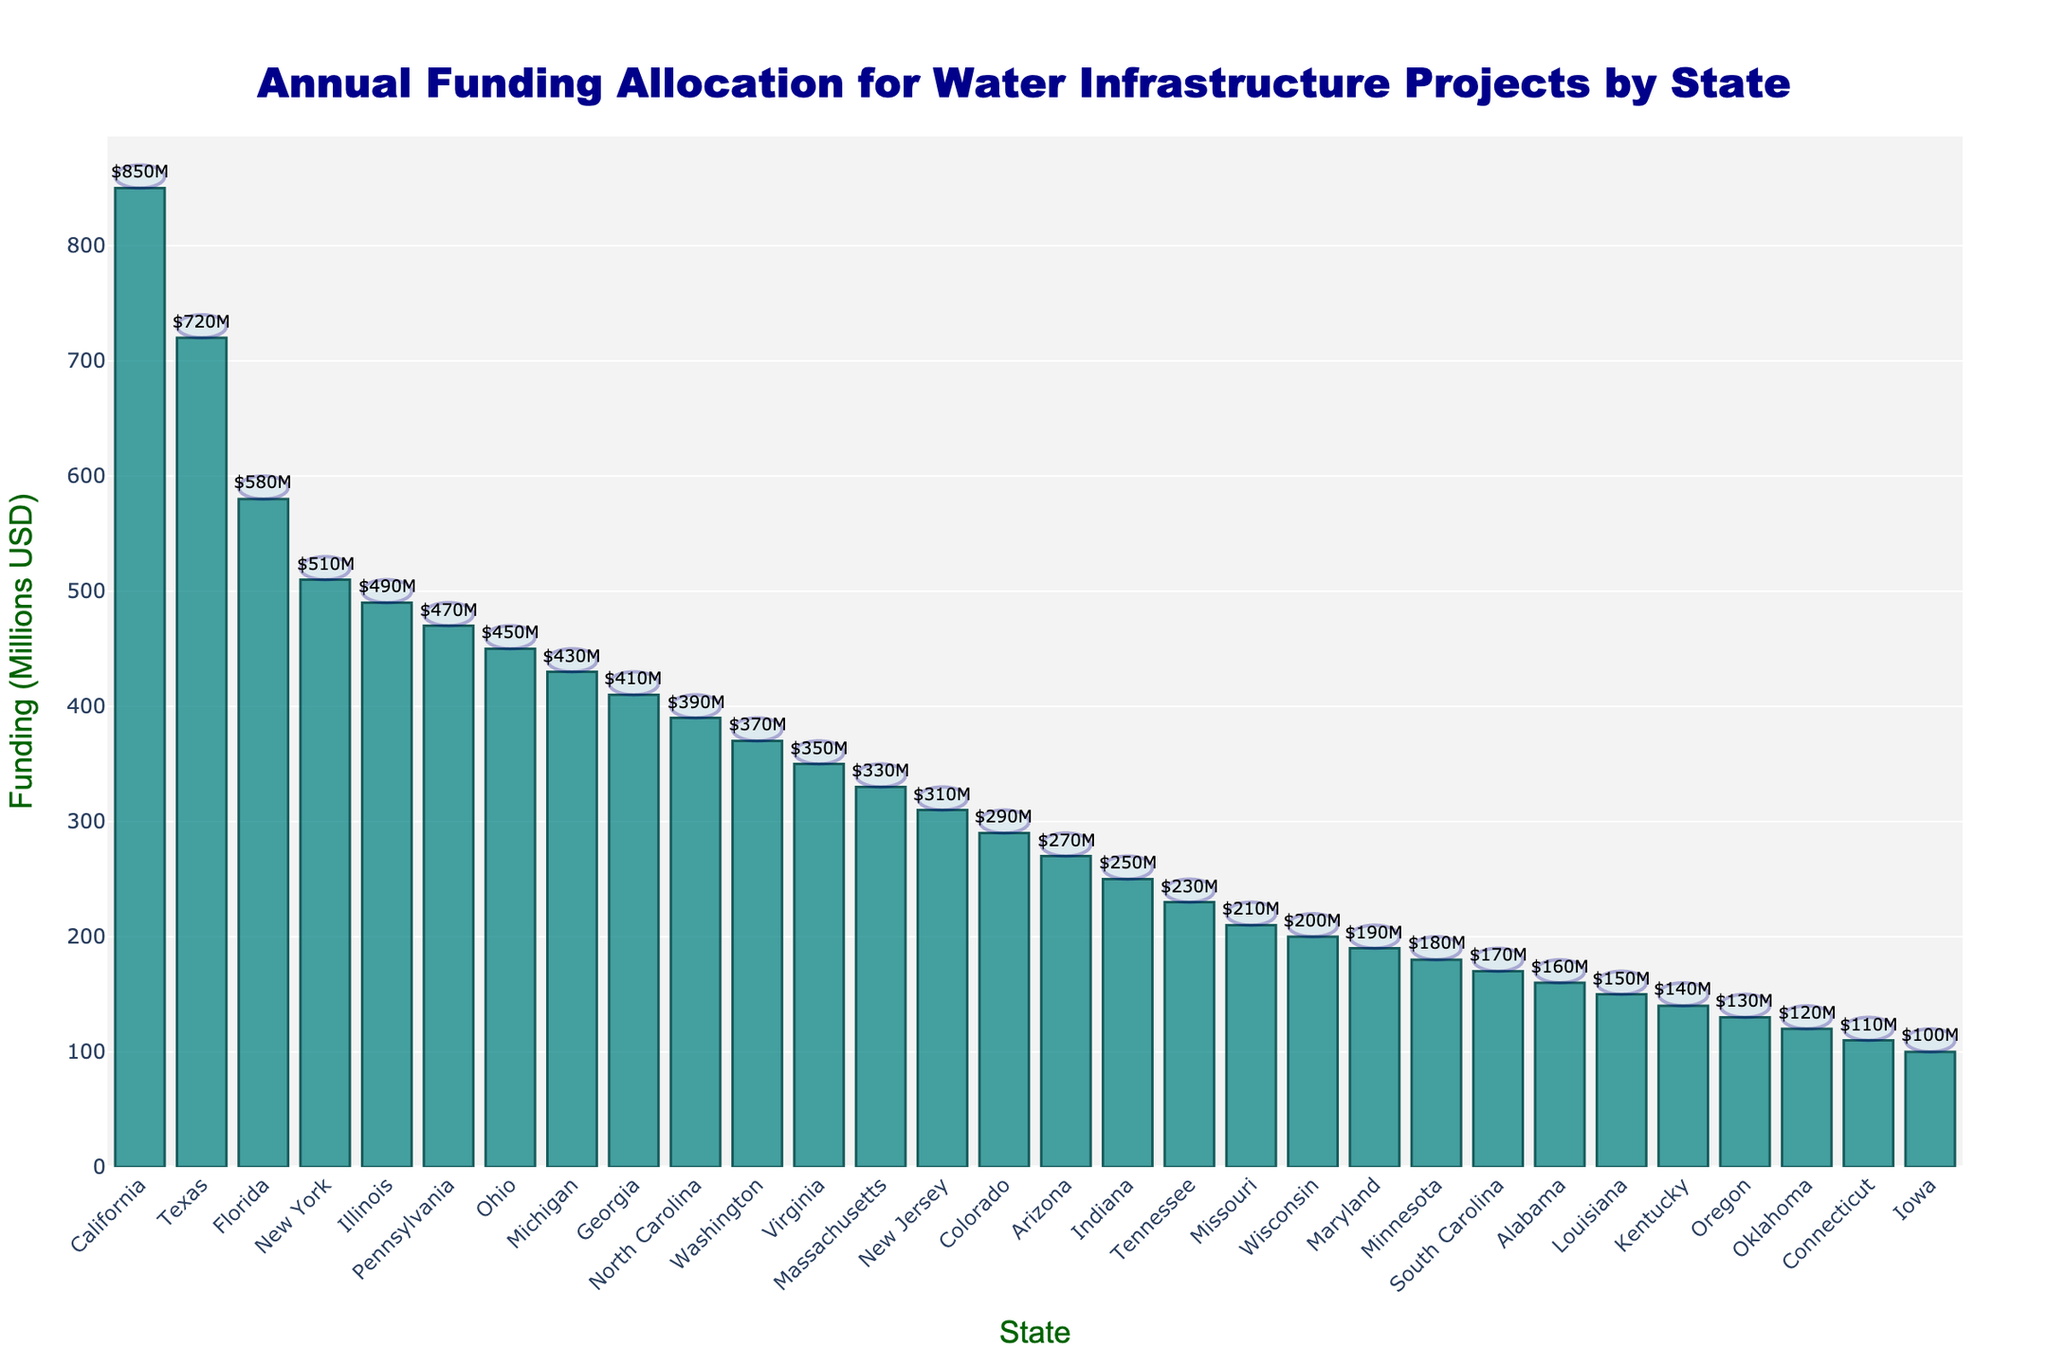Which state has the highest annual funding allocation for water infrastructure projects? By inspecting the height of the bars, we see that the bar representing California extends the highest on the y-axis, indicating this state has the greatest funding allocation.
Answer: California What's the total annual funding allocation for the top three states? Identify the top three states by the height of their bars: California ($850M), Texas ($720M), and Florida ($580M). Sum them: $850M + $720M + $580M = $2150M.
Answer: $2150M How much more funding does California receive compared to New York? Find the funding for California ($850M) and New York ($510M). Calculate the difference: $850M - $510M = $340M.
Answer: $340M Which states have funding allocations below $150M? Visually inspect the bars shorter than $150M. These states are Louisiana, Kentucky, Oregon, Oklahoma, Connecticut, and Iowa.
Answer: Louisiana, Kentucky, Oregon, Oklahoma, Connecticut, Iowa What's the average annual funding allocation for all states shown? Sum all funding values and divide by the number of states. Sum: $15460M. Number of states: 30. Average: $15460M / 30 = $515.33M.
Answer: $515.33M Compare the total funding allocations of the top 5 and bottom 5 states. Which group has a higher total, and by how much? Identify the top 5 states: California ($850M), Texas ($720M), Florida ($580M), New York ($510M), Illinois ($490M). Total: $3150M. Identify the bottom 5 states: Oklahoma ($120M), Connecticut ($110M), Iowa ($100M), Kentucky ($140M), Oregon ($130M). Total: $600M. Difference: $3150M - $600M = $2550M.
Answer: Top 5 by $2550M Is Virginia's funding closer to Ohio's or Georgia's? Find the funding for Virginia ($350M), Ohio ($450M), and Georgia ($410M). Calculate the differences: $450M - $350M = $100M, $410M - $350M = $60M. Virginia's funding is closer to Georgia's.
Answer: Georgia What percentage of the total funding allocation does the top state (California) receive? Calculate the percentage: $850M / $15460M = 0.05497. Multiply by 100 to get 5.497%.
Answer: 5.497% Are there any pairs of states with equal funding allocations? Inspect the heights and labels of all bars to compare values. All states have unique funding allocations, no two states have the same value.
Answer: No 